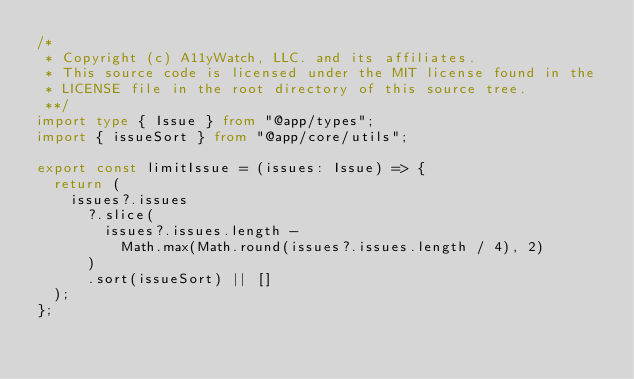<code> <loc_0><loc_0><loc_500><loc_500><_TypeScript_>/*
 * Copyright (c) A11yWatch, LLC. and its affiliates.
 * This source code is licensed under the MIT license found in the
 * LICENSE file in the root directory of this source tree.
 **/
import type { Issue } from "@app/types";
import { issueSort } from "@app/core/utils";

export const limitIssue = (issues: Issue) => {
  return (
    issues?.issues
      ?.slice(
        issues?.issues.length -
          Math.max(Math.round(issues?.issues.length / 4), 2)
      )
      .sort(issueSort) || []
  );
};
</code> 